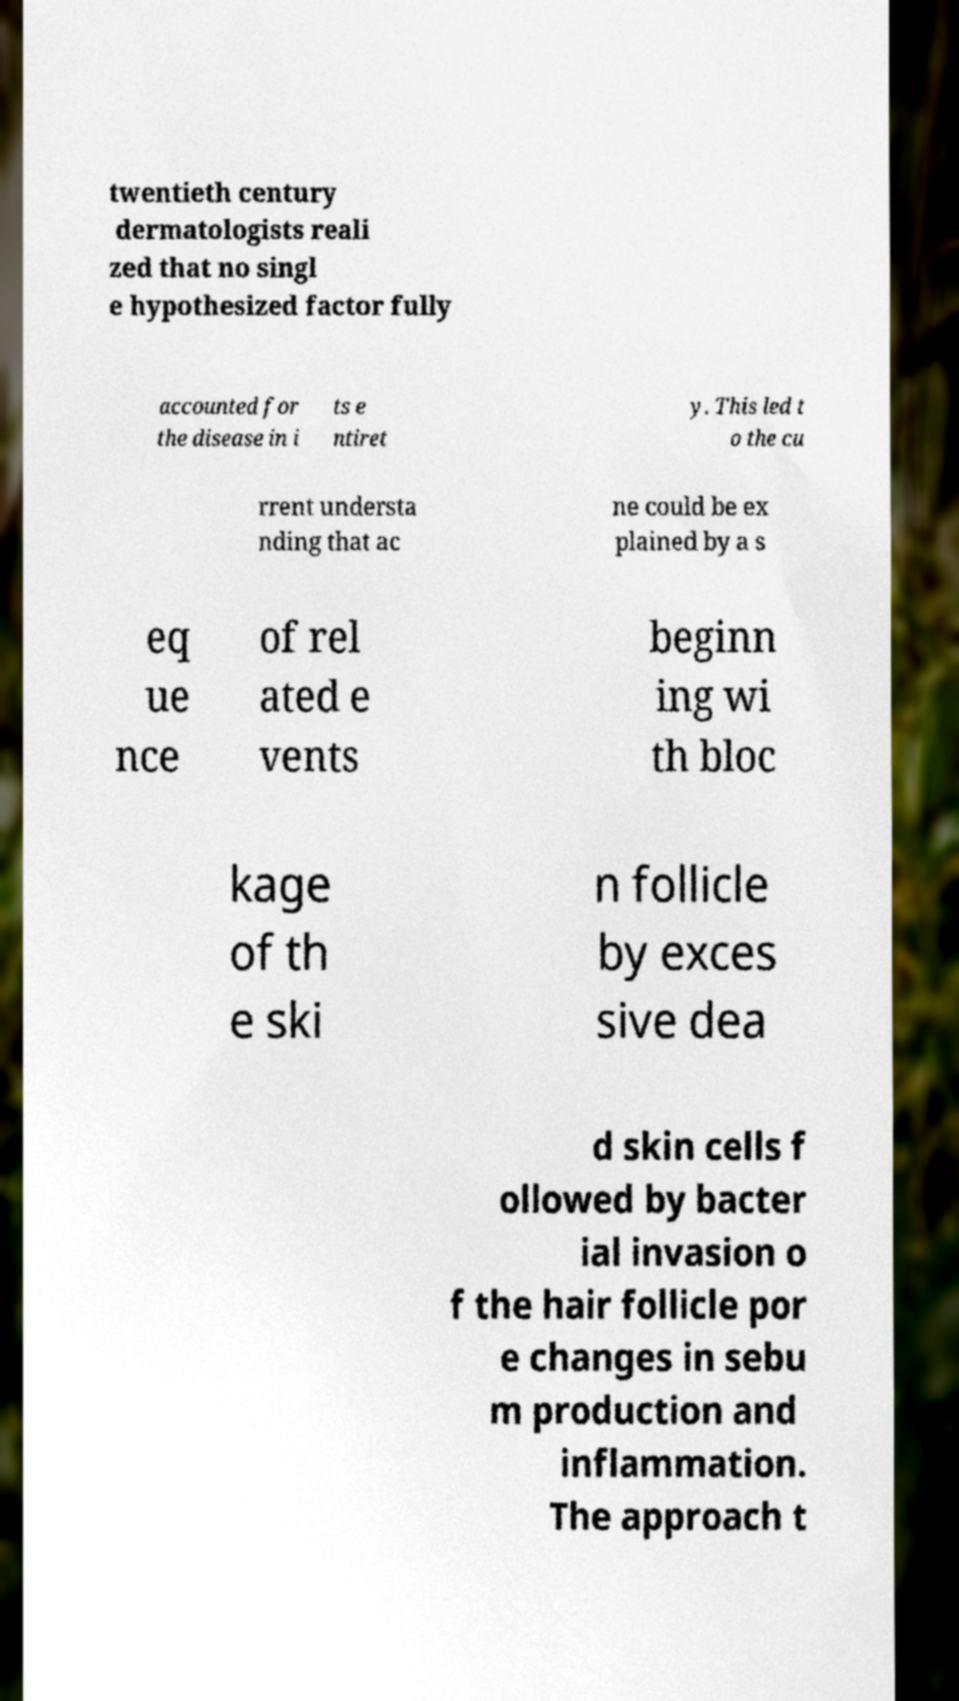Could you extract and type out the text from this image? twentieth century dermatologists reali zed that no singl e hypothesized factor fully accounted for the disease in i ts e ntiret y. This led t o the cu rrent understa nding that ac ne could be ex plained by a s eq ue nce of rel ated e vents beginn ing wi th bloc kage of th e ski n follicle by exces sive dea d skin cells f ollowed by bacter ial invasion o f the hair follicle por e changes in sebu m production and inflammation. The approach t 